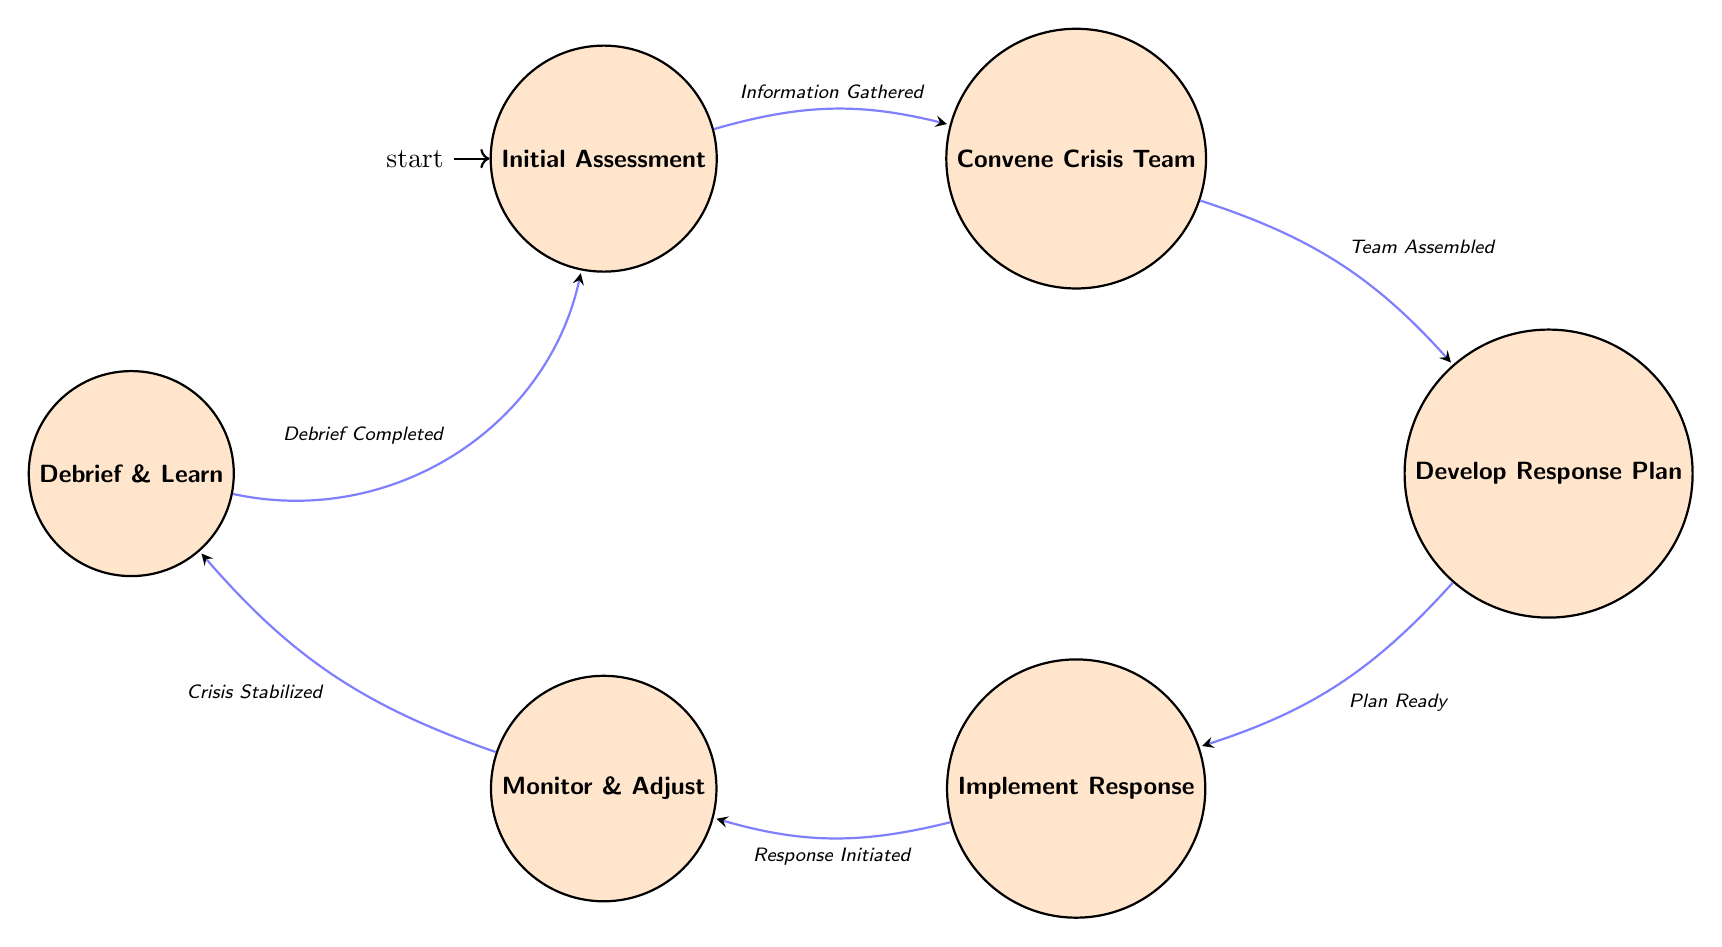What is the initial state in the diagram? The initial state is the starting point of the Finite State Machine, which is labeled as "Initial Assessment" in the diagram.
Answer: Initial Assessment How many states are present in the diagram? The diagram consists of six distinct states: Initial Assessment, Convene Crisis Team, Develop Response Plan, Implement Response, Monitor & Adjust, and Debrief & Learn.
Answer: 6 What action is associated with the "Convene Crisis Team" state? The actions for the "Convene Crisis Team" state include contacting local government officials, engaging with emergency services, and involving experienced advisers.
Answer: Contact local government officials What event leads to transitioning from "Implement Response" to "Monitor & Adjust"? The transition from "Implement Response" to "Monitor & Adjust" occurs upon the event titled "Response Initiated".
Answer: Response Initiated What is the last state before returning to the initial state? The last state prior to returning to the initial state is "Debrief & Learn", where the response is reviewed and lessons for future crises are identified.
Answer: Debrief & Learn What is the purpose of the "Monitor & Adjust" state? The purpose of the "Monitor & Adjust" state is to continuously monitor the situation and make necessary adjustments based on real-time data and effectiveness of the response.
Answer: Continuously monitor What follows after the "Crisis Stabilized" event? After the "Crisis Stabilized" event, the process transitions to the "Debrief & Learn" state, where the response's effectiveness is reviewed.
Answer: Debrief & Learn How many transitions are represented in the diagram? There are five transitions in total, each connecting the states through specified events leading from one state to another.
Answer: 5 Which state involves the creation of an actionable plan? The state that involves the creation of an actionable plan to address the crisis is "Develop Response Plan".
Answer: Develop Response Plan What is documented during the "Debrief & Learn" state? During the "Debrief & Learn" state, successes and failures of the response are documented, which helps inform future crisis management efforts.
Answer: Document successes and failures 